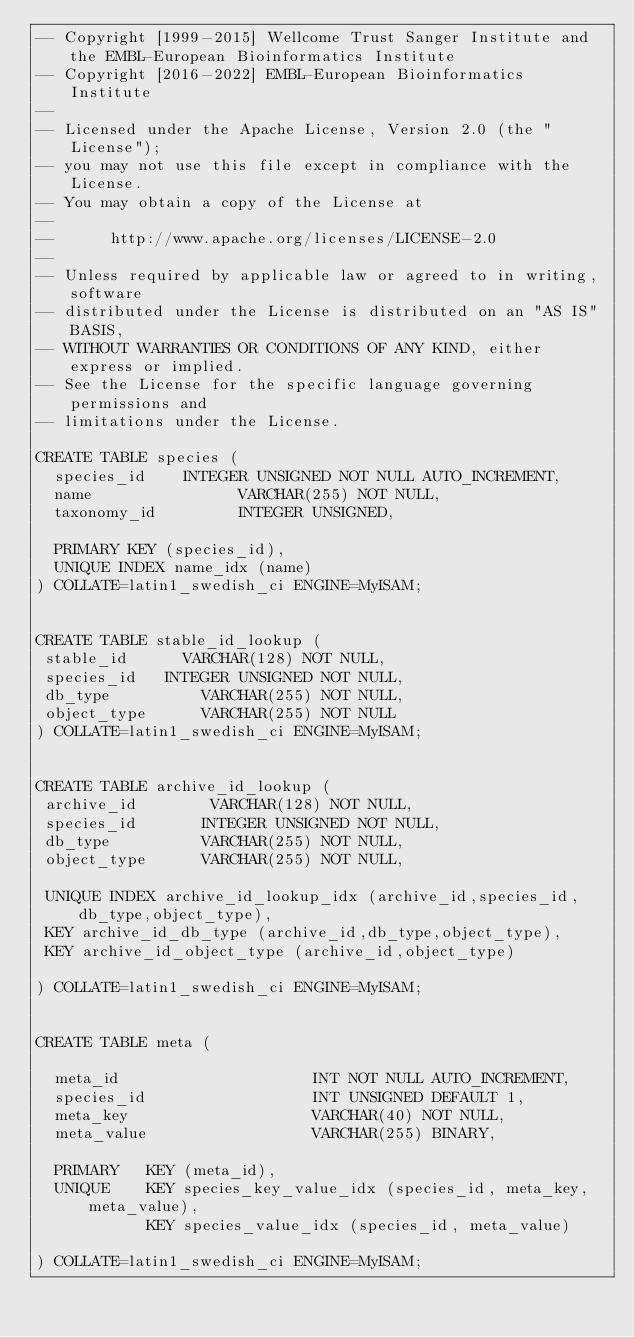Convert code to text. <code><loc_0><loc_0><loc_500><loc_500><_SQL_>-- Copyright [1999-2015] Wellcome Trust Sanger Institute and the EMBL-European Bioinformatics Institute
-- Copyright [2016-2022] EMBL-European Bioinformatics Institute
-- 
-- Licensed under the Apache License, Version 2.0 (the "License");
-- you may not use this file except in compliance with the License.
-- You may obtain a copy of the License at
-- 
--      http://www.apache.org/licenses/LICENSE-2.0
-- 
-- Unless required by applicable law or agreed to in writing, software
-- distributed under the License is distributed on an "AS IS" BASIS,
-- WITHOUT WARRANTIES OR CONDITIONS OF ANY KIND, either express or implied.
-- See the License for the specific language governing permissions and
-- limitations under the License.

CREATE TABLE species (
  species_id		INTEGER UNSIGNED NOT NULL AUTO_INCREMENT,
  name         	     	VARCHAR(255) NOT NULL,
  taxonomy_id        	INTEGER UNSIGNED,

  PRIMARY KEY (species_id),
  UNIQUE INDEX name_idx (name)
) COLLATE=latin1_swedish_ci ENGINE=MyISAM;


CREATE TABLE stable_id_lookup (
 stable_id   	  VARCHAR(128) NOT NULL,	      
 species_id	  INTEGER UNSIGNED NOT NULL,
 db_type          VARCHAR(255) NOT NULL,
 object_type   	  VARCHAR(255) NOT NULL
) COLLATE=latin1_swedish_ci ENGINE=MyISAM;


CREATE TABLE archive_id_lookup (
 archive_id        VARCHAR(128) NOT NULL,
 species_id       INTEGER UNSIGNED NOT NULL,
 db_type          VARCHAR(255) NOT NULL,
 object_type      VARCHAR(255) NOT NULL,

 UNIQUE INDEX archive_id_lookup_idx (archive_id,species_id,db_type,object_type),
 KEY archive_id_db_type (archive_id,db_type,object_type),
 KEY archive_id_object_type (archive_id,object_type)

) COLLATE=latin1_swedish_ci ENGINE=MyISAM;


CREATE TABLE meta (

  meta_id                     INT NOT NULL AUTO_INCREMENT,
  species_id                  INT UNSIGNED DEFAULT 1,
  meta_key                    VARCHAR(40) NOT NULL,
  meta_value                  VARCHAR(255) BINARY,

  PRIMARY   KEY (meta_id),
  UNIQUE    KEY species_key_value_idx (species_id, meta_key, meta_value),
            KEY species_value_idx (species_id, meta_value)

) COLLATE=latin1_swedish_ci ENGINE=MyISAM;

</code> 